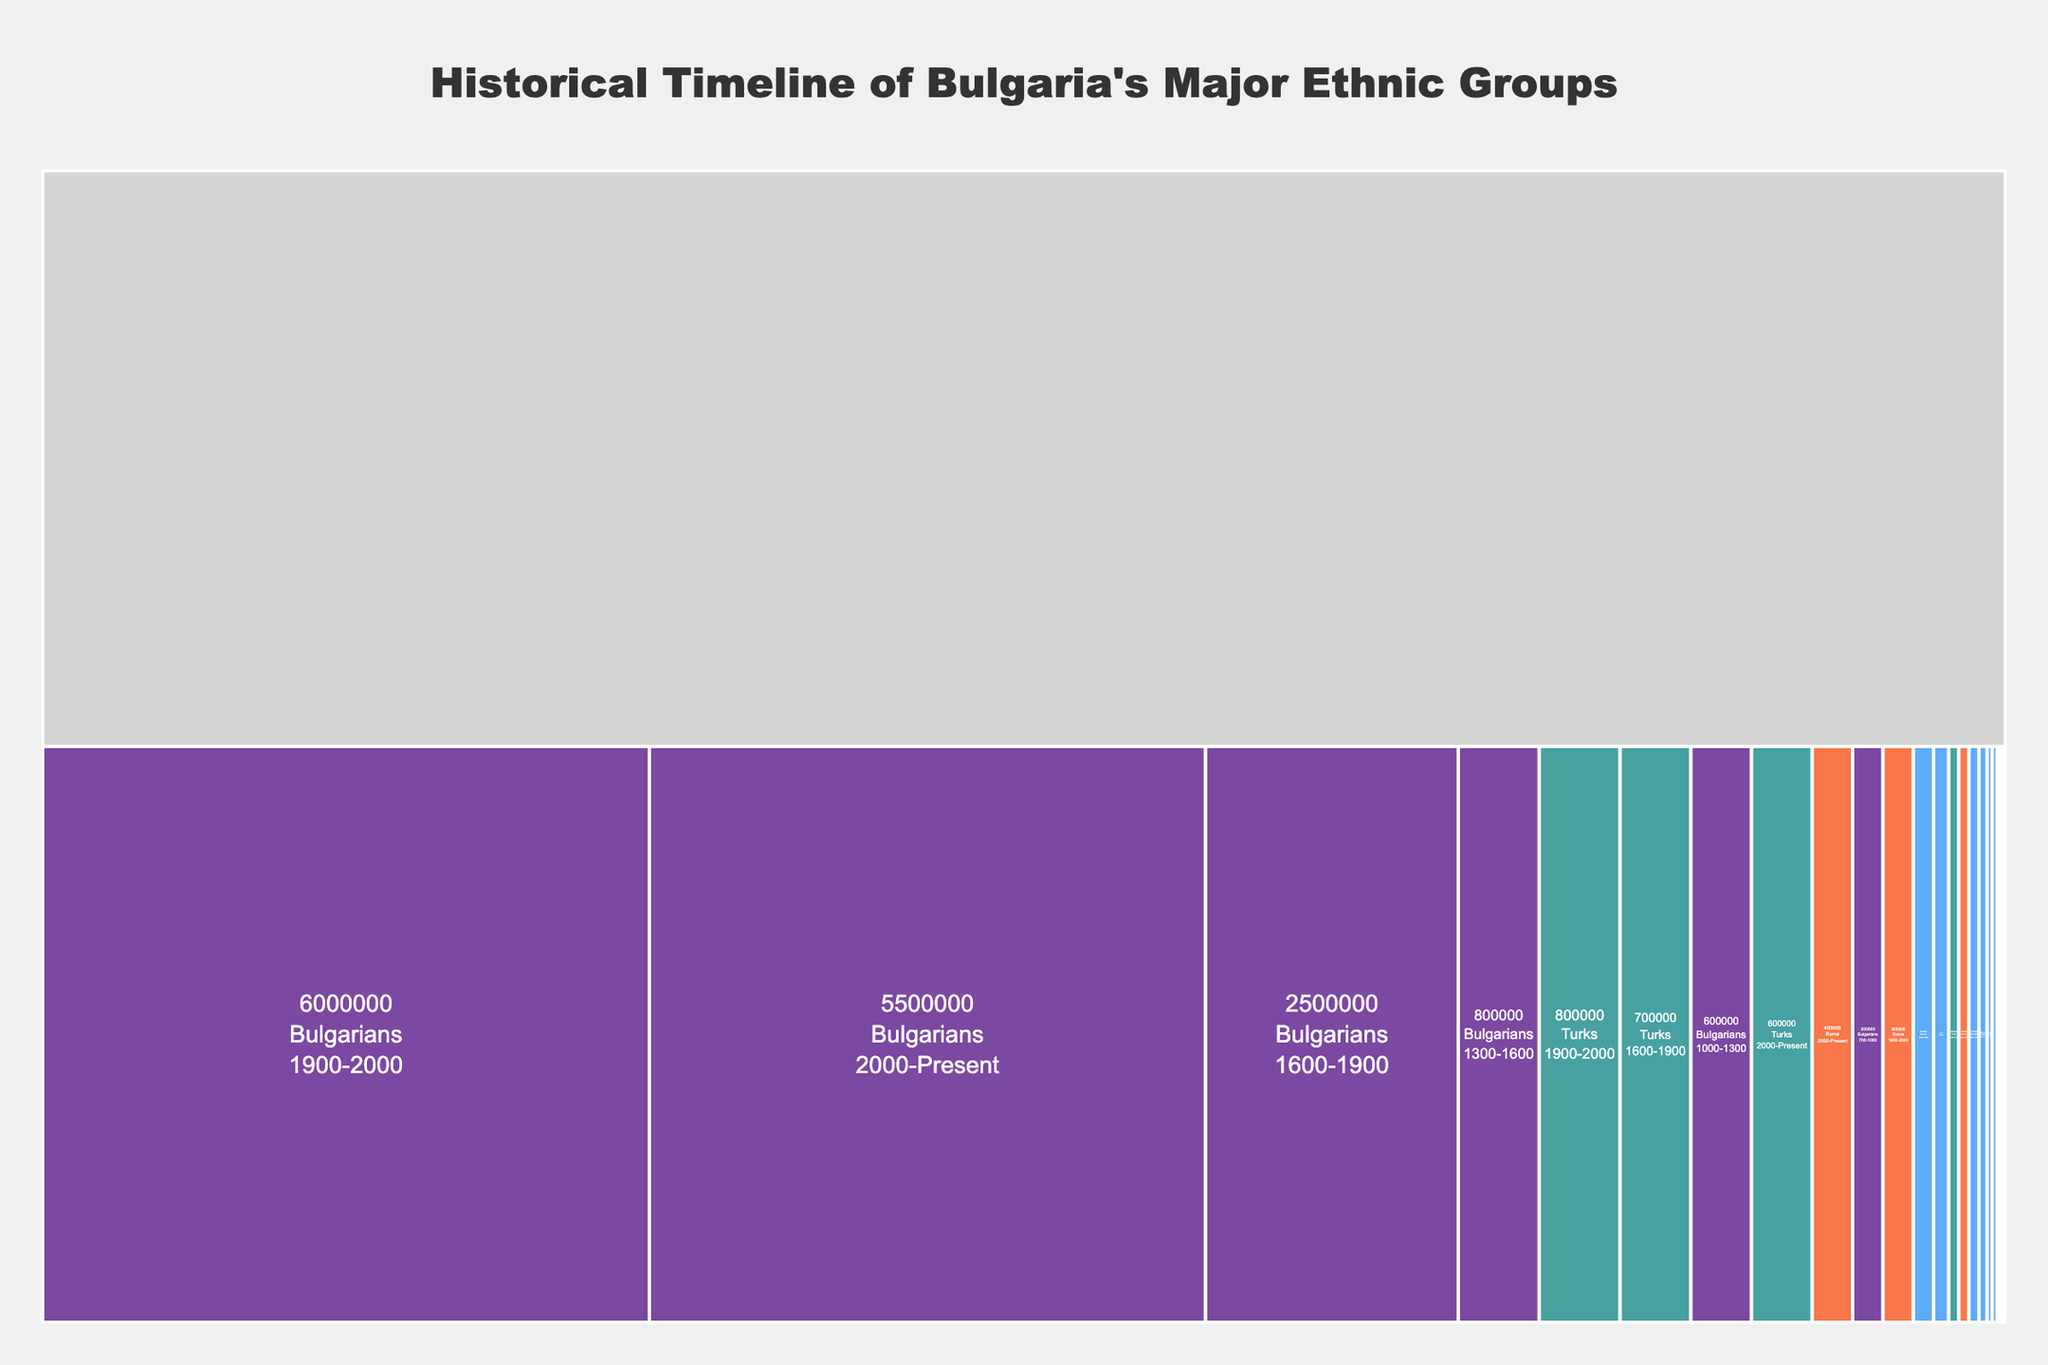What is the population of Bulgarians in the period from 700-1000? The chart indicates the populations of various ethnic groups over different time periods. Look for the segment labeled 'Bulgarians' and within that, the time range '700-1000'. The population is shown directly in the label.
Answer: 300,000 Which ethnic group has the smallest population in the period from 1300-1600? Identify the populations of each ethnic group in the time range '1300-1600' by examining each segment of the chart under that period. Compare the populations for these groups to find the smallest one.
Answer: Roma How does the population of Turks change from 1600-1900 to 2000-Present? Look at the population of Turks for both the periods '1600-1900' and '2000-Present' in the chart. Compare these two values to determine the change. The population increases from 700,000 to 600,000.
Answer: It decreases Which ethnic group had the highest population in the period from 1900-2000? Examine the population figures for each ethnic group in the time range labeled '1900-2000'. Identify the group with the highest population figure in that period.
Answer: Bulgarians What is the total population of Greeks from 700 to the present day? Sum the populations of Greeks over all time ranges: 700-1000 (50,000), 1000-1300 (80,000), 1300-1600 (100,000), 1600-1900 (200,000), 1900-2000 (150,000), and 2000-Present (50,000).
Answer: 630,000 How does the population trend of Armenians compare with that of Roma from 1900 to the present? Compare the population figures for Armenians and Roma for the periods '1900-2000' and '2000-Present'. Armenians decrease from 20,000 to 10,000, while Roma increase from 300,000 to 400,000.
Answer: Armenians decrease; Roma increase What's the population difference between Bulgarians and Turks in the period 2000-Present? Find and compare the populations of both Bulgarians and Turks for '2000-Present'. The population of Bulgarians is 5,500,000 and for Turks, it is 600,000. Subtract the latter from the former.
Answer: 4,900,000 